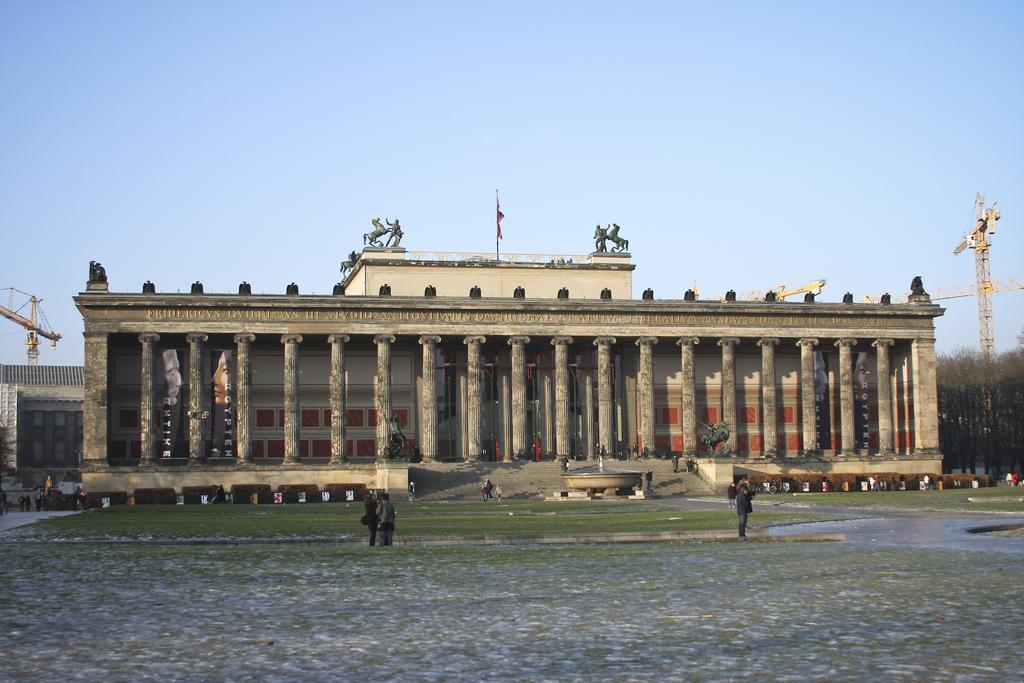Can you describe this image briefly? In the image we can see there are people standing on the road and there is a building at the back. Behind there are two construction cranes. 